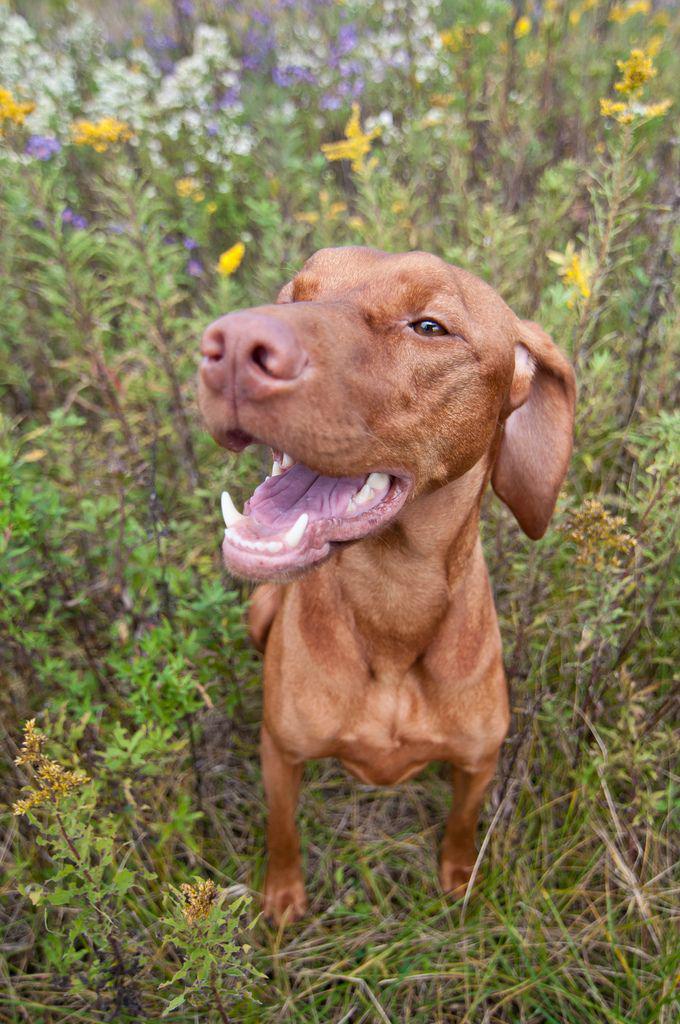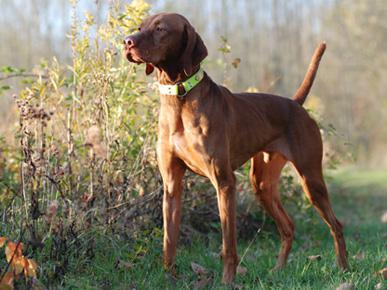The first image is the image on the left, the second image is the image on the right. Evaluate the accuracy of this statement regarding the images: "At least one dog is on a leash.". Is it true? Answer yes or no. No. The first image is the image on the left, the second image is the image on the right. Assess this claim about the two images: "There are two dogs with their mouths closed.". Correct or not? Answer yes or no. No. 